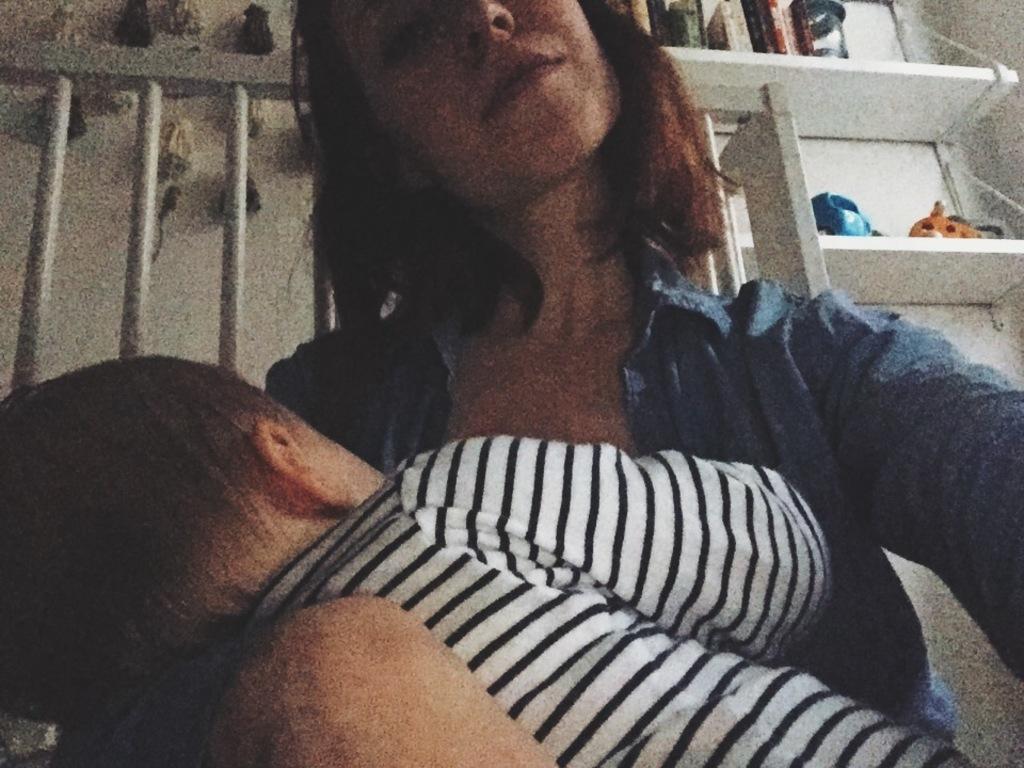Please provide a concise description of this image. In this image we can see a woman. She is wearing blue color shirt and carrying baby in her hand. Baby is wearing white and black color t-shirt. Background of the image, white color shelf is there. In the shelf, things are arranged. 